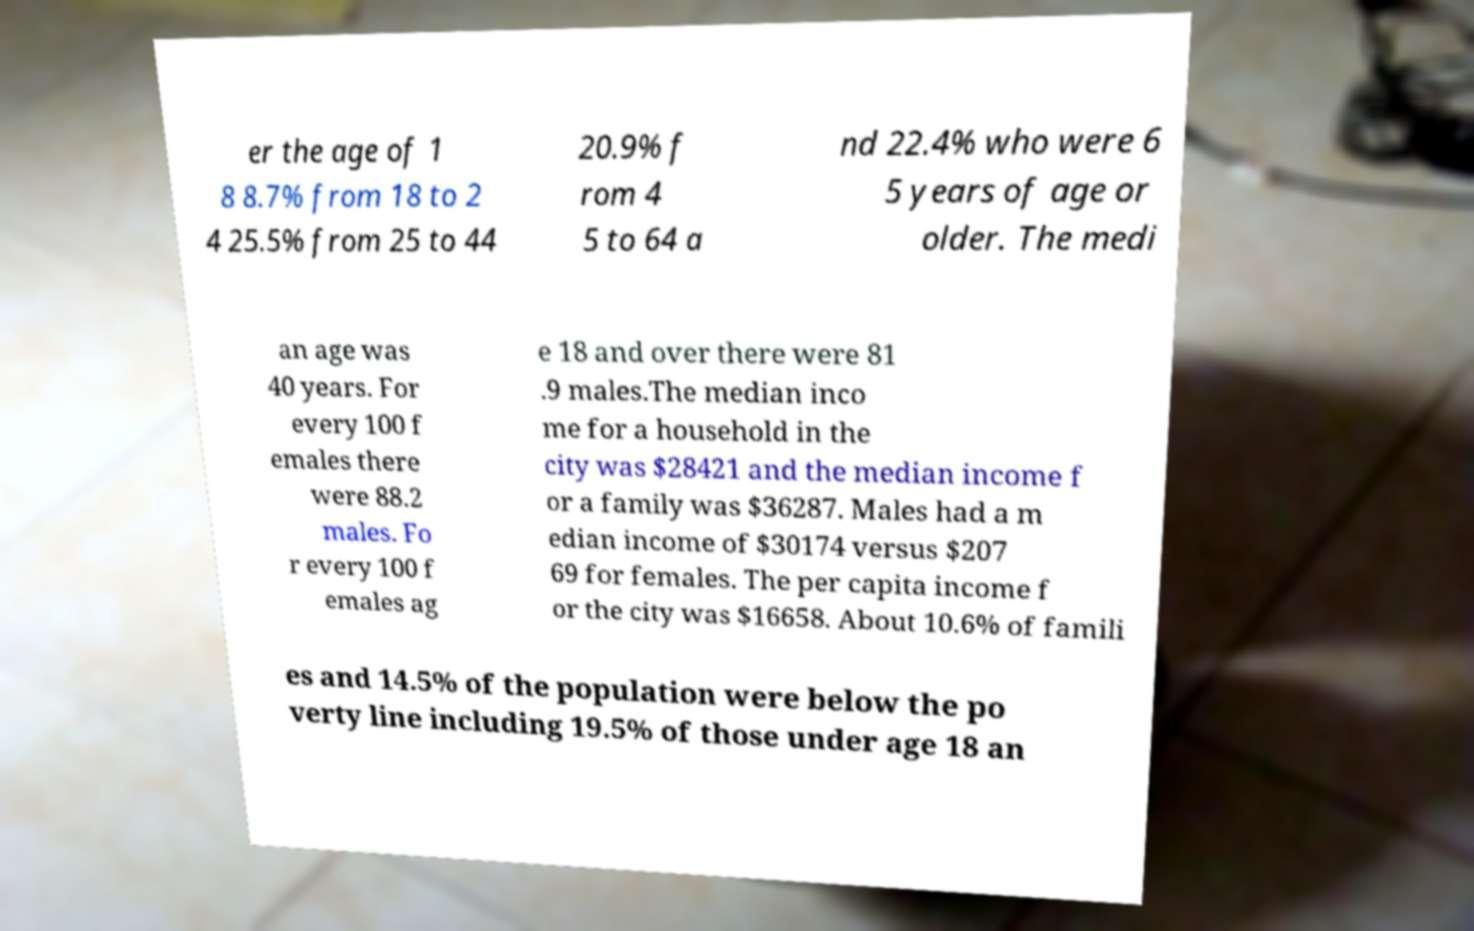I need the written content from this picture converted into text. Can you do that? er the age of 1 8 8.7% from 18 to 2 4 25.5% from 25 to 44 20.9% f rom 4 5 to 64 a nd 22.4% who were 6 5 years of age or older. The medi an age was 40 years. For every 100 f emales there were 88.2 males. Fo r every 100 f emales ag e 18 and over there were 81 .9 males.The median inco me for a household in the city was $28421 and the median income f or a family was $36287. Males had a m edian income of $30174 versus $207 69 for females. The per capita income f or the city was $16658. About 10.6% of famili es and 14.5% of the population were below the po verty line including 19.5% of those under age 18 an 